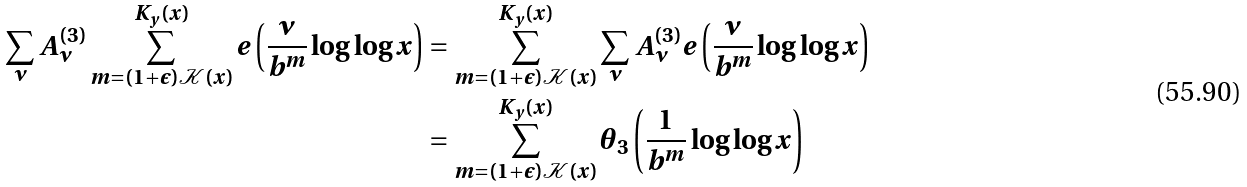<formula> <loc_0><loc_0><loc_500><loc_500>\sum _ { \nu } A _ { \nu } ^ { ( 3 ) } \sum _ { m = ( 1 + \epsilon ) \mathcal { K } ( x ) } ^ { K _ { y } ( x ) } e \left ( \frac { \nu } { b ^ { m } } \log \log x \right ) & = \sum _ { m = ( 1 + \epsilon ) \mathcal { K } ( x ) } ^ { K _ { y } ( x ) } \sum _ { \nu } A _ { \nu } ^ { ( 3 ) } e \left ( \frac { \nu } { b ^ { m } } \log \log x \right ) \\ & = \sum _ { m = ( 1 + \epsilon ) \mathcal { K } ( x ) } ^ { K _ { y } ( x ) } \theta _ { 3 } \left ( \frac { 1 } { b ^ { m } } \log \log x \right )</formula> 